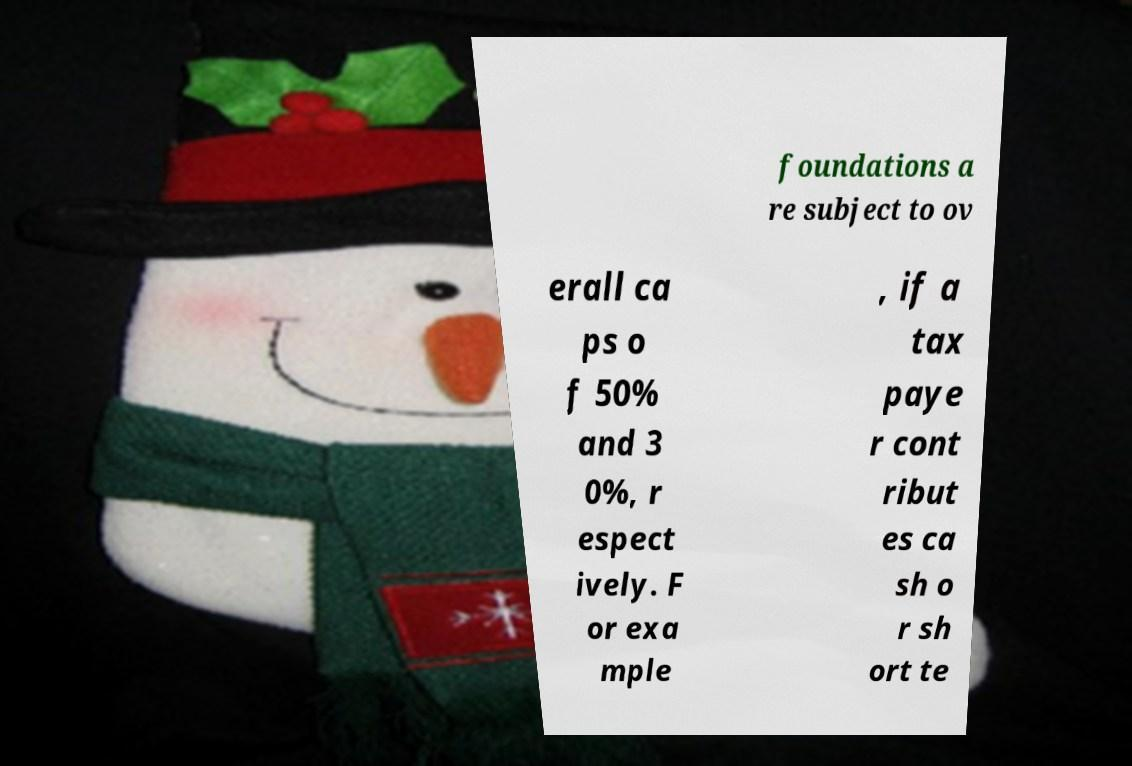Please read and relay the text visible in this image. What does it say? foundations a re subject to ov erall ca ps o f 50% and 3 0%, r espect ively. F or exa mple , if a tax paye r cont ribut es ca sh o r sh ort te 